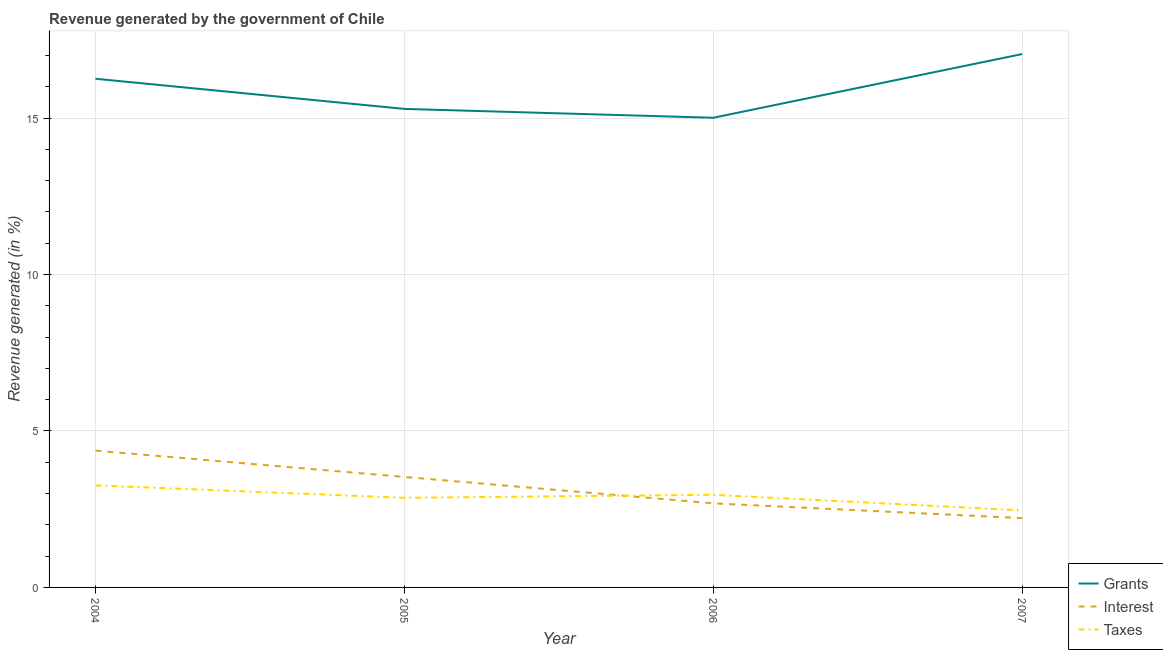Does the line corresponding to percentage of revenue generated by taxes intersect with the line corresponding to percentage of revenue generated by grants?
Your answer should be very brief. No. Is the number of lines equal to the number of legend labels?
Your answer should be compact. Yes. What is the percentage of revenue generated by taxes in 2006?
Keep it short and to the point. 2.96. Across all years, what is the maximum percentage of revenue generated by grants?
Your answer should be compact. 17.05. Across all years, what is the minimum percentage of revenue generated by interest?
Make the answer very short. 2.22. In which year was the percentage of revenue generated by interest maximum?
Keep it short and to the point. 2004. What is the total percentage of revenue generated by interest in the graph?
Keep it short and to the point. 12.8. What is the difference between the percentage of revenue generated by taxes in 2004 and that in 2007?
Offer a very short reply. 0.8. What is the difference between the percentage of revenue generated by grants in 2006 and the percentage of revenue generated by taxes in 2005?
Your answer should be very brief. 12.15. What is the average percentage of revenue generated by grants per year?
Make the answer very short. 15.9. In the year 2004, what is the difference between the percentage of revenue generated by interest and percentage of revenue generated by grants?
Your response must be concise. -11.88. In how many years, is the percentage of revenue generated by taxes greater than 8 %?
Keep it short and to the point. 0. What is the ratio of the percentage of revenue generated by grants in 2005 to that in 2006?
Provide a succinct answer. 1.02. Is the percentage of revenue generated by taxes in 2004 less than that in 2007?
Your response must be concise. No. What is the difference between the highest and the second highest percentage of revenue generated by interest?
Offer a terse response. 0.84. What is the difference between the highest and the lowest percentage of revenue generated by taxes?
Provide a succinct answer. 0.8. In how many years, is the percentage of revenue generated by interest greater than the average percentage of revenue generated by interest taken over all years?
Keep it short and to the point. 2. How many lines are there?
Give a very brief answer. 3. Does the graph contain any zero values?
Keep it short and to the point. No. Does the graph contain grids?
Your answer should be very brief. Yes. Where does the legend appear in the graph?
Provide a short and direct response. Bottom right. How many legend labels are there?
Your answer should be compact. 3. What is the title of the graph?
Your answer should be very brief. Revenue generated by the government of Chile. What is the label or title of the X-axis?
Make the answer very short. Year. What is the label or title of the Y-axis?
Your answer should be compact. Revenue generated (in %). What is the Revenue generated (in %) in Grants in 2004?
Offer a terse response. 16.26. What is the Revenue generated (in %) in Interest in 2004?
Provide a succinct answer. 4.37. What is the Revenue generated (in %) of Taxes in 2004?
Give a very brief answer. 3.26. What is the Revenue generated (in %) of Grants in 2005?
Make the answer very short. 15.29. What is the Revenue generated (in %) of Interest in 2005?
Keep it short and to the point. 3.53. What is the Revenue generated (in %) of Taxes in 2005?
Provide a short and direct response. 2.86. What is the Revenue generated (in %) in Grants in 2006?
Your response must be concise. 15.01. What is the Revenue generated (in %) in Interest in 2006?
Provide a succinct answer. 2.69. What is the Revenue generated (in %) in Taxes in 2006?
Provide a succinct answer. 2.96. What is the Revenue generated (in %) of Grants in 2007?
Your answer should be very brief. 17.05. What is the Revenue generated (in %) of Interest in 2007?
Keep it short and to the point. 2.22. What is the Revenue generated (in %) of Taxes in 2007?
Your response must be concise. 2.46. Across all years, what is the maximum Revenue generated (in %) in Grants?
Provide a short and direct response. 17.05. Across all years, what is the maximum Revenue generated (in %) in Interest?
Offer a terse response. 4.37. Across all years, what is the maximum Revenue generated (in %) of Taxes?
Provide a succinct answer. 3.26. Across all years, what is the minimum Revenue generated (in %) of Grants?
Ensure brevity in your answer.  15.01. Across all years, what is the minimum Revenue generated (in %) of Interest?
Make the answer very short. 2.22. Across all years, what is the minimum Revenue generated (in %) in Taxes?
Ensure brevity in your answer.  2.46. What is the total Revenue generated (in %) of Grants in the graph?
Keep it short and to the point. 63.6. What is the total Revenue generated (in %) of Interest in the graph?
Give a very brief answer. 12.8. What is the total Revenue generated (in %) in Taxes in the graph?
Your answer should be very brief. 11.55. What is the difference between the Revenue generated (in %) in Grants in 2004 and that in 2005?
Ensure brevity in your answer.  0.96. What is the difference between the Revenue generated (in %) of Interest in 2004 and that in 2005?
Your response must be concise. 0.84. What is the difference between the Revenue generated (in %) of Taxes in 2004 and that in 2005?
Ensure brevity in your answer.  0.4. What is the difference between the Revenue generated (in %) in Grants in 2004 and that in 2006?
Keep it short and to the point. 1.25. What is the difference between the Revenue generated (in %) in Interest in 2004 and that in 2006?
Provide a short and direct response. 1.68. What is the difference between the Revenue generated (in %) in Taxes in 2004 and that in 2006?
Make the answer very short. 0.3. What is the difference between the Revenue generated (in %) in Grants in 2004 and that in 2007?
Make the answer very short. -0.79. What is the difference between the Revenue generated (in %) in Interest in 2004 and that in 2007?
Your response must be concise. 2.16. What is the difference between the Revenue generated (in %) of Taxes in 2004 and that in 2007?
Provide a succinct answer. 0.8. What is the difference between the Revenue generated (in %) of Grants in 2005 and that in 2006?
Your response must be concise. 0.28. What is the difference between the Revenue generated (in %) in Interest in 2005 and that in 2006?
Your response must be concise. 0.84. What is the difference between the Revenue generated (in %) in Taxes in 2005 and that in 2006?
Provide a succinct answer. -0.1. What is the difference between the Revenue generated (in %) of Grants in 2005 and that in 2007?
Ensure brevity in your answer.  -1.75. What is the difference between the Revenue generated (in %) in Interest in 2005 and that in 2007?
Your response must be concise. 1.32. What is the difference between the Revenue generated (in %) of Taxes in 2005 and that in 2007?
Make the answer very short. 0.4. What is the difference between the Revenue generated (in %) in Grants in 2006 and that in 2007?
Keep it short and to the point. -2.04. What is the difference between the Revenue generated (in %) of Interest in 2006 and that in 2007?
Your answer should be very brief. 0.47. What is the difference between the Revenue generated (in %) of Taxes in 2006 and that in 2007?
Your answer should be very brief. 0.5. What is the difference between the Revenue generated (in %) of Grants in 2004 and the Revenue generated (in %) of Interest in 2005?
Your answer should be compact. 12.72. What is the difference between the Revenue generated (in %) of Grants in 2004 and the Revenue generated (in %) of Taxes in 2005?
Your answer should be compact. 13.39. What is the difference between the Revenue generated (in %) of Interest in 2004 and the Revenue generated (in %) of Taxes in 2005?
Your answer should be very brief. 1.51. What is the difference between the Revenue generated (in %) of Grants in 2004 and the Revenue generated (in %) of Interest in 2006?
Keep it short and to the point. 13.57. What is the difference between the Revenue generated (in %) in Grants in 2004 and the Revenue generated (in %) in Taxes in 2006?
Provide a short and direct response. 13.29. What is the difference between the Revenue generated (in %) of Interest in 2004 and the Revenue generated (in %) of Taxes in 2006?
Your answer should be very brief. 1.41. What is the difference between the Revenue generated (in %) in Grants in 2004 and the Revenue generated (in %) in Interest in 2007?
Make the answer very short. 14.04. What is the difference between the Revenue generated (in %) of Grants in 2004 and the Revenue generated (in %) of Taxes in 2007?
Offer a very short reply. 13.79. What is the difference between the Revenue generated (in %) in Interest in 2004 and the Revenue generated (in %) in Taxes in 2007?
Your answer should be very brief. 1.91. What is the difference between the Revenue generated (in %) in Grants in 2005 and the Revenue generated (in %) in Interest in 2006?
Give a very brief answer. 12.61. What is the difference between the Revenue generated (in %) in Grants in 2005 and the Revenue generated (in %) in Taxes in 2006?
Offer a very short reply. 12.33. What is the difference between the Revenue generated (in %) in Interest in 2005 and the Revenue generated (in %) in Taxes in 2006?
Make the answer very short. 0.57. What is the difference between the Revenue generated (in %) in Grants in 2005 and the Revenue generated (in %) in Interest in 2007?
Ensure brevity in your answer.  13.08. What is the difference between the Revenue generated (in %) in Grants in 2005 and the Revenue generated (in %) in Taxes in 2007?
Your answer should be very brief. 12.83. What is the difference between the Revenue generated (in %) in Interest in 2005 and the Revenue generated (in %) in Taxes in 2007?
Provide a short and direct response. 1.07. What is the difference between the Revenue generated (in %) of Grants in 2006 and the Revenue generated (in %) of Interest in 2007?
Provide a short and direct response. 12.79. What is the difference between the Revenue generated (in %) in Grants in 2006 and the Revenue generated (in %) in Taxes in 2007?
Offer a very short reply. 12.55. What is the difference between the Revenue generated (in %) of Interest in 2006 and the Revenue generated (in %) of Taxes in 2007?
Make the answer very short. 0.23. What is the average Revenue generated (in %) of Grants per year?
Offer a terse response. 15.9. What is the average Revenue generated (in %) in Interest per year?
Your answer should be compact. 3.2. What is the average Revenue generated (in %) of Taxes per year?
Your response must be concise. 2.89. In the year 2004, what is the difference between the Revenue generated (in %) in Grants and Revenue generated (in %) in Interest?
Your answer should be very brief. 11.88. In the year 2004, what is the difference between the Revenue generated (in %) of Grants and Revenue generated (in %) of Taxes?
Give a very brief answer. 12.99. In the year 2004, what is the difference between the Revenue generated (in %) in Interest and Revenue generated (in %) in Taxes?
Offer a terse response. 1.11. In the year 2005, what is the difference between the Revenue generated (in %) of Grants and Revenue generated (in %) of Interest?
Your answer should be compact. 11.76. In the year 2005, what is the difference between the Revenue generated (in %) in Grants and Revenue generated (in %) in Taxes?
Offer a terse response. 12.43. In the year 2005, what is the difference between the Revenue generated (in %) of Interest and Revenue generated (in %) of Taxes?
Offer a very short reply. 0.67. In the year 2006, what is the difference between the Revenue generated (in %) in Grants and Revenue generated (in %) in Interest?
Offer a very short reply. 12.32. In the year 2006, what is the difference between the Revenue generated (in %) of Grants and Revenue generated (in %) of Taxes?
Your answer should be compact. 12.05. In the year 2006, what is the difference between the Revenue generated (in %) of Interest and Revenue generated (in %) of Taxes?
Provide a short and direct response. -0.27. In the year 2007, what is the difference between the Revenue generated (in %) of Grants and Revenue generated (in %) of Interest?
Your response must be concise. 14.83. In the year 2007, what is the difference between the Revenue generated (in %) in Grants and Revenue generated (in %) in Taxes?
Keep it short and to the point. 14.58. In the year 2007, what is the difference between the Revenue generated (in %) in Interest and Revenue generated (in %) in Taxes?
Provide a succinct answer. -0.25. What is the ratio of the Revenue generated (in %) in Grants in 2004 to that in 2005?
Give a very brief answer. 1.06. What is the ratio of the Revenue generated (in %) in Interest in 2004 to that in 2005?
Your answer should be compact. 1.24. What is the ratio of the Revenue generated (in %) in Taxes in 2004 to that in 2005?
Keep it short and to the point. 1.14. What is the ratio of the Revenue generated (in %) in Grants in 2004 to that in 2006?
Your response must be concise. 1.08. What is the ratio of the Revenue generated (in %) of Interest in 2004 to that in 2006?
Your answer should be very brief. 1.63. What is the ratio of the Revenue generated (in %) of Taxes in 2004 to that in 2006?
Your answer should be compact. 1.1. What is the ratio of the Revenue generated (in %) in Grants in 2004 to that in 2007?
Provide a short and direct response. 0.95. What is the ratio of the Revenue generated (in %) in Interest in 2004 to that in 2007?
Make the answer very short. 1.97. What is the ratio of the Revenue generated (in %) in Taxes in 2004 to that in 2007?
Make the answer very short. 1.33. What is the ratio of the Revenue generated (in %) of Grants in 2005 to that in 2006?
Make the answer very short. 1.02. What is the ratio of the Revenue generated (in %) in Interest in 2005 to that in 2006?
Offer a very short reply. 1.31. What is the ratio of the Revenue generated (in %) in Taxes in 2005 to that in 2006?
Provide a succinct answer. 0.97. What is the ratio of the Revenue generated (in %) in Grants in 2005 to that in 2007?
Provide a succinct answer. 0.9. What is the ratio of the Revenue generated (in %) in Interest in 2005 to that in 2007?
Offer a terse response. 1.59. What is the ratio of the Revenue generated (in %) of Taxes in 2005 to that in 2007?
Your response must be concise. 1.16. What is the ratio of the Revenue generated (in %) of Grants in 2006 to that in 2007?
Provide a short and direct response. 0.88. What is the ratio of the Revenue generated (in %) of Interest in 2006 to that in 2007?
Give a very brief answer. 1.21. What is the ratio of the Revenue generated (in %) in Taxes in 2006 to that in 2007?
Ensure brevity in your answer.  1.2. What is the difference between the highest and the second highest Revenue generated (in %) of Grants?
Make the answer very short. 0.79. What is the difference between the highest and the second highest Revenue generated (in %) in Interest?
Your response must be concise. 0.84. What is the difference between the highest and the second highest Revenue generated (in %) of Taxes?
Your response must be concise. 0.3. What is the difference between the highest and the lowest Revenue generated (in %) of Grants?
Your answer should be very brief. 2.04. What is the difference between the highest and the lowest Revenue generated (in %) of Interest?
Provide a short and direct response. 2.16. What is the difference between the highest and the lowest Revenue generated (in %) of Taxes?
Ensure brevity in your answer.  0.8. 